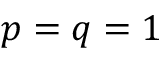Convert formula to latex. <formula><loc_0><loc_0><loc_500><loc_500>p = q = 1</formula> 